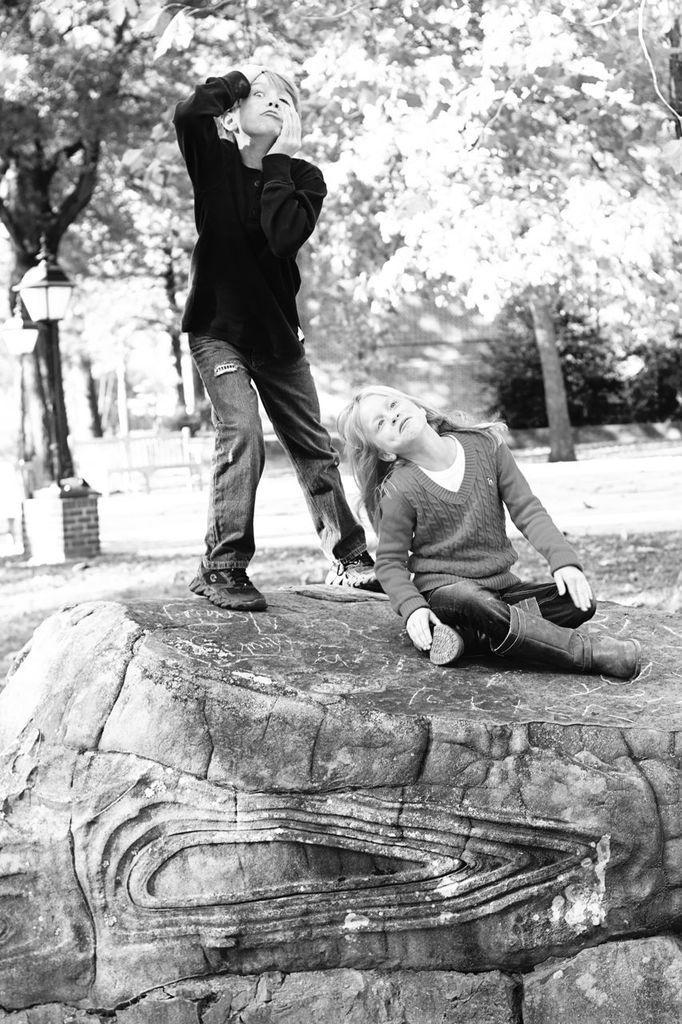Can you describe this image briefly? It looks like a black and white picture. We can see two kids on the path and behind the kids there are trees and some other items. 